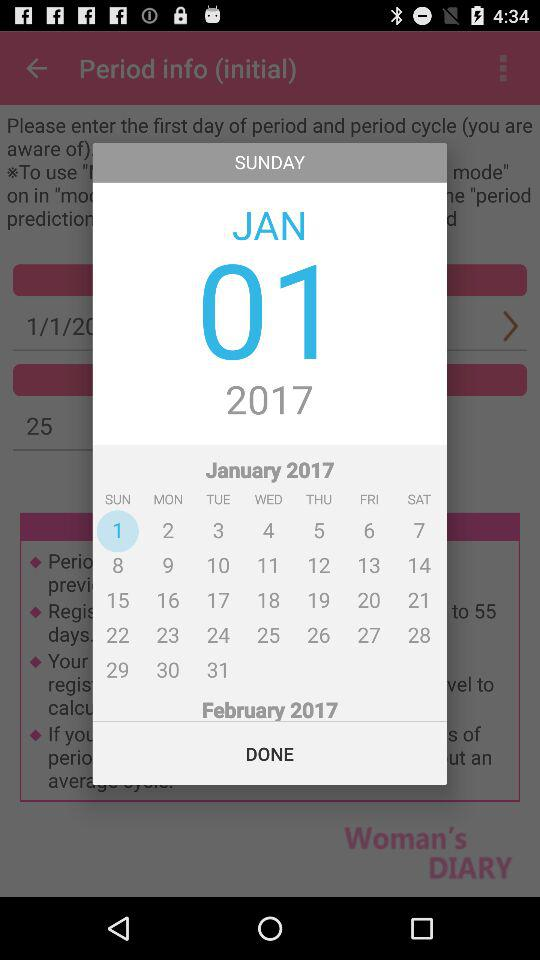What is the current month shown on the calendar? The shown month is January. 